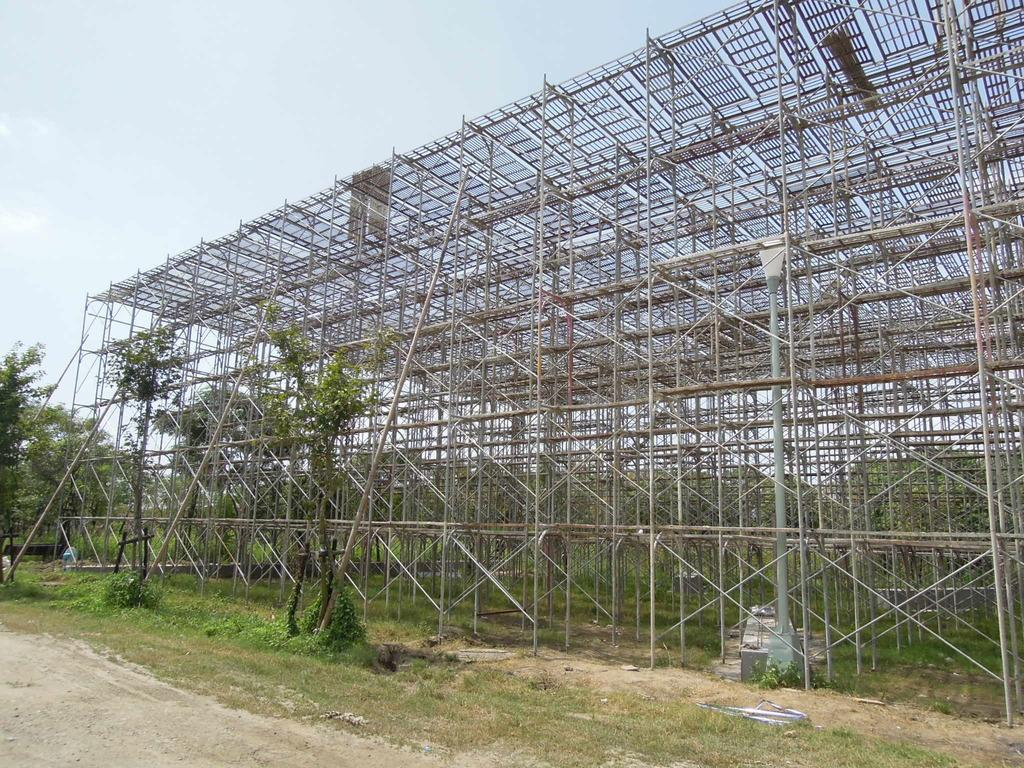What type of structure is present in the image? There is a scaffolding in the image. What type of vegetation can be seen in the image? There are trees and grass in the image. What part of the natural environment is visible in the image? The sky is visible in the image. Where is the zoo located in the image? There is no zoo present in the image. What type of cap is the scaffolding wearing in the image? Scaffolding does not wear caps, as it is an inanimate object. 